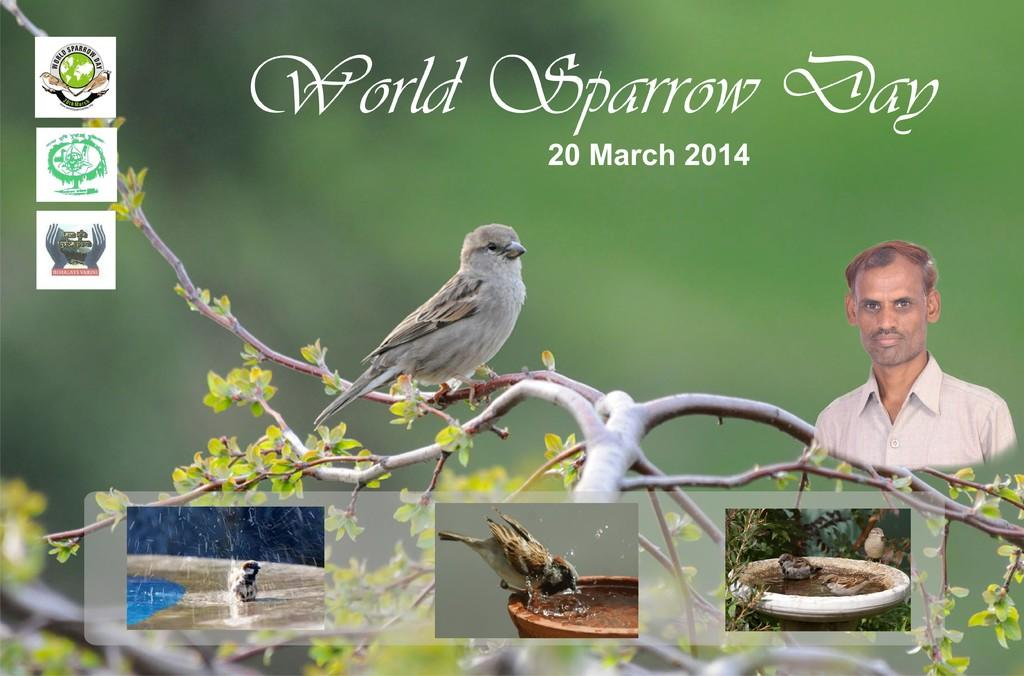What is featured on the banner in the image? The banner contains a tree branch, a nest, and birds. Can you describe the nest on the banner? There is a nest on the banner. What else can be seen on the banner? There is a man on the right side of the banner. What type of action is the rabbit performing on the banner? There is no rabbit present on the banner; it features a tree branch, a nest, birds, and a man. 